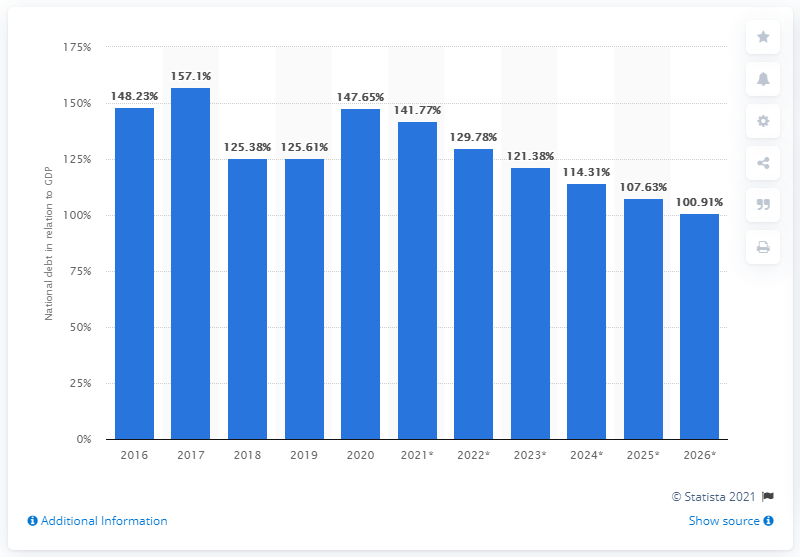List a handful of essential elements in this visual. In 2020, Barbados' national debt accounted for approximately 147.65% of the country's Gross Domestic Product (GDP), indicating a significant financial burden on the economy. 